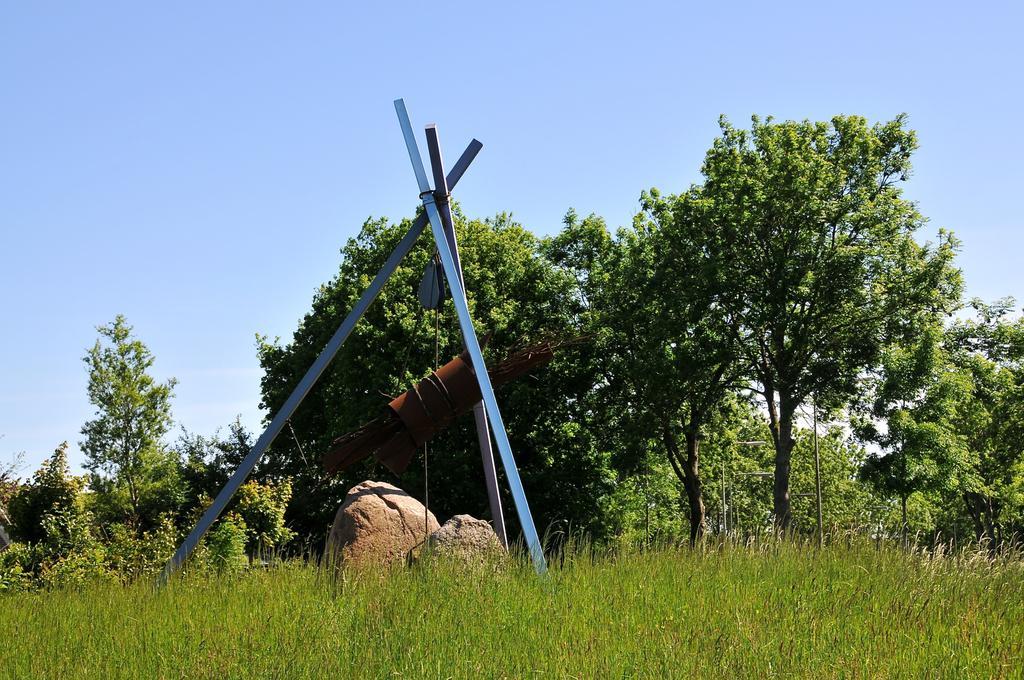Can you describe this image briefly? In this image we can see grass and rocks. There is an object tied to the poles. In the background we can see plants, trees, poles and sky. 